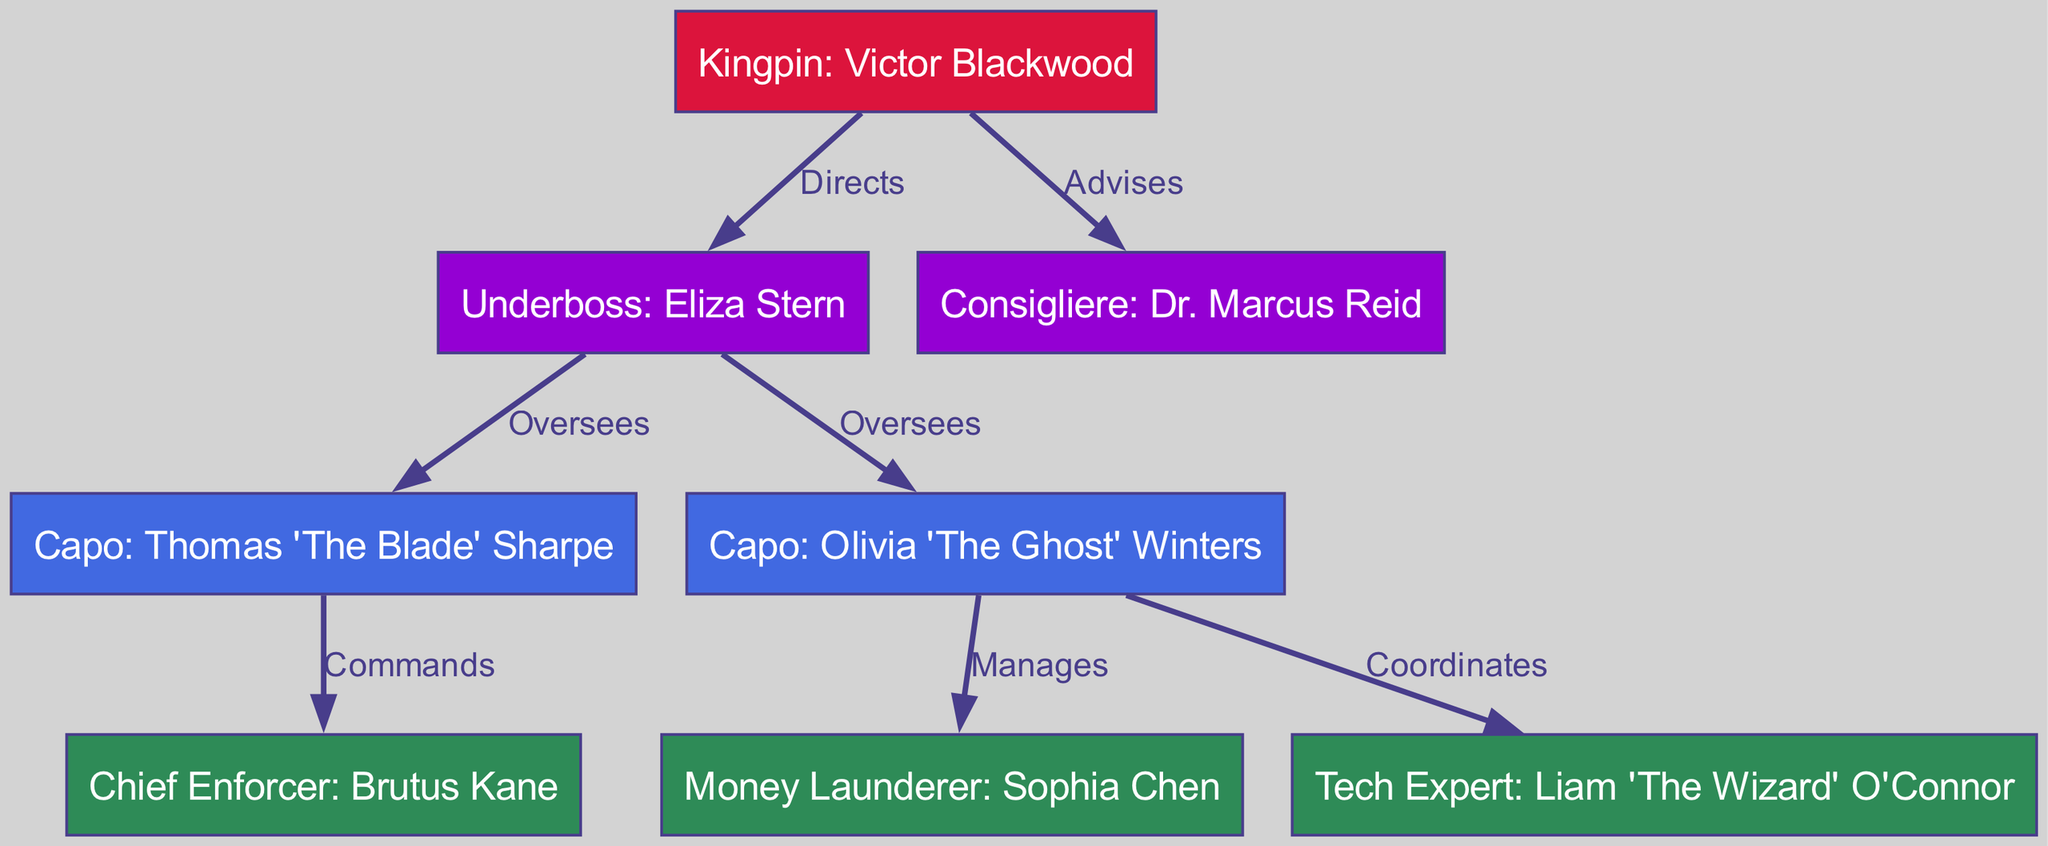What is the label of the top node? The top node represents the leader of the organization and is labeled as "Kingpin: Victor Blackwood".
Answer: Kingpin: Victor Blackwood How many Capos are there in the organization? There are two Capos listed in the organization: Thomas 'The Blade' Sharpe and Olivia 'The Ghost' Winters.
Answer: 2 Who does the Underboss oversee? The Underboss oversees two Capos: Thomas 'The Blade' Sharpe and Olivia 'The Ghost' Winters.
Answer: Capo: Thomas 'The Blade' Sharpe, Capo: Olivia 'The Ghost' Winters What is the role of Sophia Chen in the organization? Sophia Chen is designated as the Money Launderer in the organizational hierarchy.
Answer: Money Launderer: Sophia Chen Which node advises the Boss? The node that advises the Boss is the Consigliere, specifically Dr. Marcus Reid.
Answer: Consigliere: Dr. Marcus Reid How many edges are there in total in the diagram? Counting all the directed relationships between nodes, there are a total of seven edges.
Answer: 7 Who commands the Chief Enforcer? The Chief Enforcer, Brutus Kane, is commanded by Capo1, Thomas 'The Blade' Sharpe.
Answer: Capo: Thomas 'The Blade' Sharpe What is the relationship between Olivia 'The Ghost' Winters and Sophia Chen? Olivia 'The Ghost' Winters manages Sophia Chen as part of her role in the organization.
Answer: Manages Which node has the role of Tech Expert? The role of Tech Expert is assigned to Liam 'The Wizard' O'Connor in the hierarchy.
Answer: Tech Expert: Liam 'The Wizard' O'Connor 